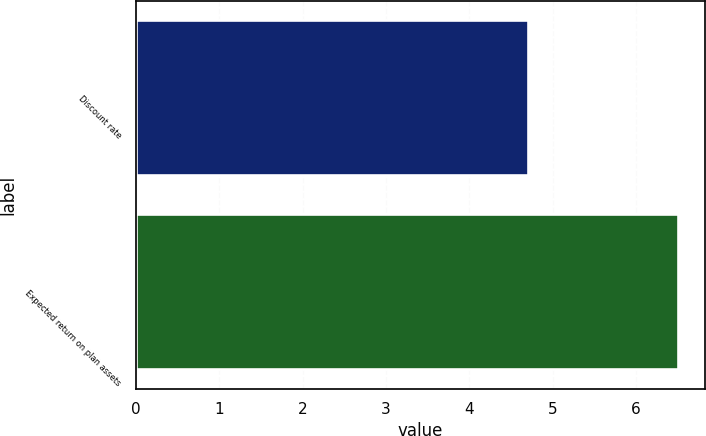Convert chart to OTSL. <chart><loc_0><loc_0><loc_500><loc_500><bar_chart><fcel>Discount rate<fcel>Expected return on plan assets<nl><fcel>4.7<fcel>6.5<nl></chart> 